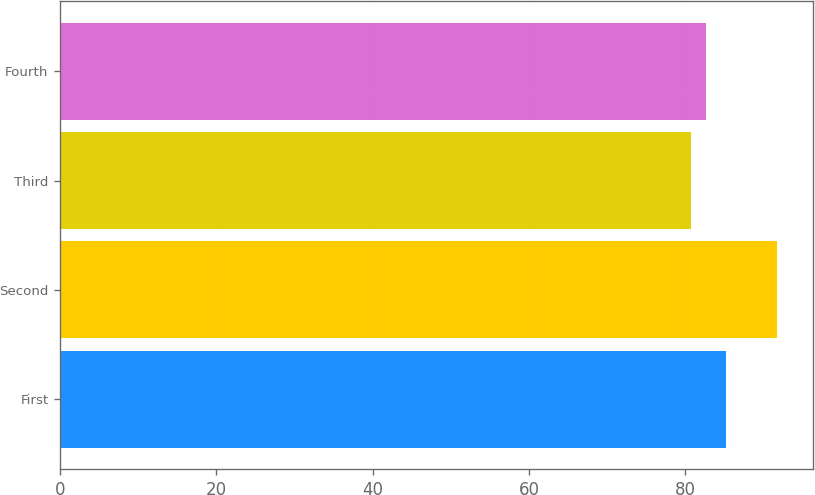Convert chart. <chart><loc_0><loc_0><loc_500><loc_500><bar_chart><fcel>First<fcel>Second<fcel>Third<fcel>Fourth<nl><fcel>85.19<fcel>91.8<fcel>80.73<fcel>82.7<nl></chart> 